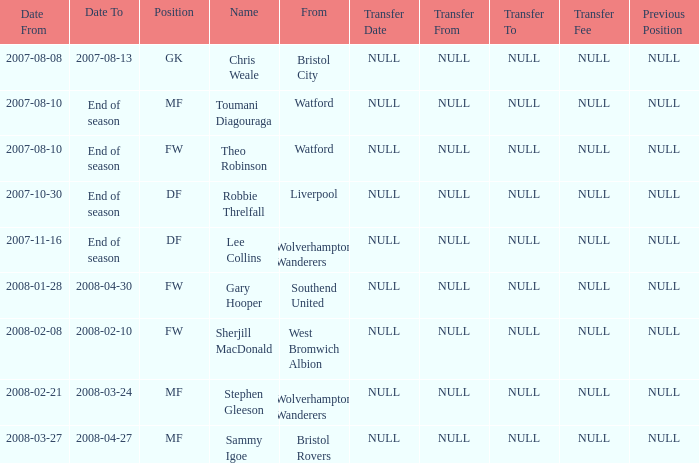On which date did toumani diagouraga, holding the role of mf, begin? 2007-08-10. 